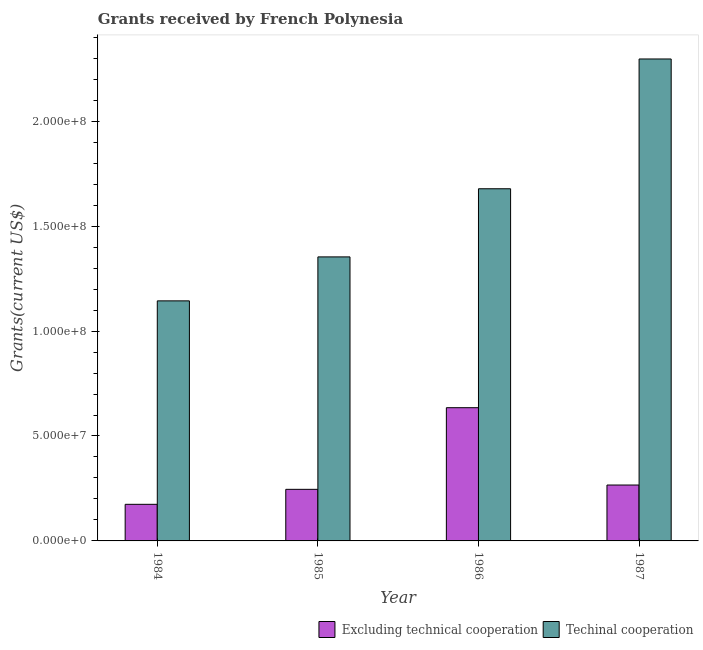How many different coloured bars are there?
Your answer should be very brief. 2. How many bars are there on the 1st tick from the left?
Your answer should be very brief. 2. How many bars are there on the 3rd tick from the right?
Ensure brevity in your answer.  2. What is the label of the 3rd group of bars from the left?
Offer a very short reply. 1986. In how many cases, is the number of bars for a given year not equal to the number of legend labels?
Your answer should be compact. 0. What is the amount of grants received(including technical cooperation) in 1984?
Your answer should be very brief. 1.14e+08. Across all years, what is the maximum amount of grants received(excluding technical cooperation)?
Keep it short and to the point. 6.35e+07. Across all years, what is the minimum amount of grants received(excluding technical cooperation)?
Your answer should be compact. 1.74e+07. What is the total amount of grants received(including technical cooperation) in the graph?
Offer a terse response. 6.47e+08. What is the difference between the amount of grants received(excluding technical cooperation) in 1985 and that in 1986?
Your answer should be very brief. -3.89e+07. What is the difference between the amount of grants received(including technical cooperation) in 1986 and the amount of grants received(excluding technical cooperation) in 1987?
Give a very brief answer. -6.18e+07. What is the average amount of grants received(excluding technical cooperation) per year?
Give a very brief answer. 3.30e+07. In how many years, is the amount of grants received(excluding technical cooperation) greater than 170000000 US$?
Make the answer very short. 0. What is the ratio of the amount of grants received(including technical cooperation) in 1984 to that in 1985?
Ensure brevity in your answer.  0.85. What is the difference between the highest and the second highest amount of grants received(including technical cooperation)?
Provide a short and direct response. 6.18e+07. What is the difference between the highest and the lowest amount of grants received(including technical cooperation)?
Offer a very short reply. 1.15e+08. In how many years, is the amount of grants received(excluding technical cooperation) greater than the average amount of grants received(excluding technical cooperation) taken over all years?
Your answer should be very brief. 1. What does the 1st bar from the left in 1986 represents?
Give a very brief answer. Excluding technical cooperation. What does the 2nd bar from the right in 1987 represents?
Offer a very short reply. Excluding technical cooperation. Are all the bars in the graph horizontal?
Offer a terse response. No. Does the graph contain any zero values?
Your response must be concise. No. Does the graph contain grids?
Provide a succinct answer. No. How many legend labels are there?
Provide a short and direct response. 2. How are the legend labels stacked?
Your answer should be compact. Horizontal. What is the title of the graph?
Provide a short and direct response. Grants received by French Polynesia. What is the label or title of the X-axis?
Provide a succinct answer. Year. What is the label or title of the Y-axis?
Your response must be concise. Grants(current US$). What is the Grants(current US$) in Excluding technical cooperation in 1984?
Provide a succinct answer. 1.74e+07. What is the Grants(current US$) of Techinal cooperation in 1984?
Your answer should be very brief. 1.14e+08. What is the Grants(current US$) of Excluding technical cooperation in 1985?
Your answer should be very brief. 2.46e+07. What is the Grants(current US$) of Techinal cooperation in 1985?
Your answer should be compact. 1.35e+08. What is the Grants(current US$) in Excluding technical cooperation in 1986?
Make the answer very short. 6.35e+07. What is the Grants(current US$) in Techinal cooperation in 1986?
Offer a terse response. 1.68e+08. What is the Grants(current US$) of Excluding technical cooperation in 1987?
Provide a succinct answer. 2.66e+07. What is the Grants(current US$) in Techinal cooperation in 1987?
Ensure brevity in your answer.  2.30e+08. Across all years, what is the maximum Grants(current US$) in Excluding technical cooperation?
Ensure brevity in your answer.  6.35e+07. Across all years, what is the maximum Grants(current US$) of Techinal cooperation?
Provide a short and direct response. 2.30e+08. Across all years, what is the minimum Grants(current US$) of Excluding technical cooperation?
Offer a terse response. 1.74e+07. Across all years, what is the minimum Grants(current US$) of Techinal cooperation?
Provide a short and direct response. 1.14e+08. What is the total Grants(current US$) in Excluding technical cooperation in the graph?
Your answer should be compact. 1.32e+08. What is the total Grants(current US$) in Techinal cooperation in the graph?
Offer a very short reply. 6.47e+08. What is the difference between the Grants(current US$) in Excluding technical cooperation in 1984 and that in 1985?
Ensure brevity in your answer.  -7.14e+06. What is the difference between the Grants(current US$) in Techinal cooperation in 1984 and that in 1985?
Ensure brevity in your answer.  -2.10e+07. What is the difference between the Grants(current US$) in Excluding technical cooperation in 1984 and that in 1986?
Provide a short and direct response. -4.60e+07. What is the difference between the Grants(current US$) in Techinal cooperation in 1984 and that in 1986?
Provide a short and direct response. -5.34e+07. What is the difference between the Grants(current US$) of Excluding technical cooperation in 1984 and that in 1987?
Offer a terse response. -9.20e+06. What is the difference between the Grants(current US$) of Techinal cooperation in 1984 and that in 1987?
Give a very brief answer. -1.15e+08. What is the difference between the Grants(current US$) of Excluding technical cooperation in 1985 and that in 1986?
Provide a succinct answer. -3.89e+07. What is the difference between the Grants(current US$) in Techinal cooperation in 1985 and that in 1986?
Offer a terse response. -3.25e+07. What is the difference between the Grants(current US$) in Excluding technical cooperation in 1985 and that in 1987?
Provide a succinct answer. -2.06e+06. What is the difference between the Grants(current US$) of Techinal cooperation in 1985 and that in 1987?
Offer a terse response. -9.43e+07. What is the difference between the Grants(current US$) in Excluding technical cooperation in 1986 and that in 1987?
Make the answer very short. 3.68e+07. What is the difference between the Grants(current US$) in Techinal cooperation in 1986 and that in 1987?
Offer a very short reply. -6.18e+07. What is the difference between the Grants(current US$) in Excluding technical cooperation in 1984 and the Grants(current US$) in Techinal cooperation in 1985?
Give a very brief answer. -1.18e+08. What is the difference between the Grants(current US$) in Excluding technical cooperation in 1984 and the Grants(current US$) in Techinal cooperation in 1986?
Make the answer very short. -1.50e+08. What is the difference between the Grants(current US$) of Excluding technical cooperation in 1984 and the Grants(current US$) of Techinal cooperation in 1987?
Give a very brief answer. -2.12e+08. What is the difference between the Grants(current US$) in Excluding technical cooperation in 1985 and the Grants(current US$) in Techinal cooperation in 1986?
Keep it short and to the point. -1.43e+08. What is the difference between the Grants(current US$) in Excluding technical cooperation in 1985 and the Grants(current US$) in Techinal cooperation in 1987?
Provide a short and direct response. -2.05e+08. What is the difference between the Grants(current US$) of Excluding technical cooperation in 1986 and the Grants(current US$) of Techinal cooperation in 1987?
Offer a very short reply. -1.66e+08. What is the average Grants(current US$) of Excluding technical cooperation per year?
Your answer should be compact. 3.30e+07. What is the average Grants(current US$) in Techinal cooperation per year?
Ensure brevity in your answer.  1.62e+08. In the year 1984, what is the difference between the Grants(current US$) in Excluding technical cooperation and Grants(current US$) in Techinal cooperation?
Your response must be concise. -9.70e+07. In the year 1985, what is the difference between the Grants(current US$) of Excluding technical cooperation and Grants(current US$) of Techinal cooperation?
Provide a succinct answer. -1.11e+08. In the year 1986, what is the difference between the Grants(current US$) of Excluding technical cooperation and Grants(current US$) of Techinal cooperation?
Provide a succinct answer. -1.04e+08. In the year 1987, what is the difference between the Grants(current US$) in Excluding technical cooperation and Grants(current US$) in Techinal cooperation?
Offer a very short reply. -2.03e+08. What is the ratio of the Grants(current US$) in Excluding technical cooperation in 1984 to that in 1985?
Give a very brief answer. 0.71. What is the ratio of the Grants(current US$) of Techinal cooperation in 1984 to that in 1985?
Provide a short and direct response. 0.85. What is the ratio of the Grants(current US$) of Excluding technical cooperation in 1984 to that in 1986?
Make the answer very short. 0.27. What is the ratio of the Grants(current US$) of Techinal cooperation in 1984 to that in 1986?
Offer a very short reply. 0.68. What is the ratio of the Grants(current US$) of Excluding technical cooperation in 1984 to that in 1987?
Give a very brief answer. 0.65. What is the ratio of the Grants(current US$) of Techinal cooperation in 1984 to that in 1987?
Your answer should be very brief. 0.5. What is the ratio of the Grants(current US$) of Excluding technical cooperation in 1985 to that in 1986?
Provide a short and direct response. 0.39. What is the ratio of the Grants(current US$) in Techinal cooperation in 1985 to that in 1986?
Provide a succinct answer. 0.81. What is the ratio of the Grants(current US$) of Excluding technical cooperation in 1985 to that in 1987?
Your answer should be very brief. 0.92. What is the ratio of the Grants(current US$) in Techinal cooperation in 1985 to that in 1987?
Your response must be concise. 0.59. What is the ratio of the Grants(current US$) of Excluding technical cooperation in 1986 to that in 1987?
Ensure brevity in your answer.  2.38. What is the ratio of the Grants(current US$) of Techinal cooperation in 1986 to that in 1987?
Ensure brevity in your answer.  0.73. What is the difference between the highest and the second highest Grants(current US$) of Excluding technical cooperation?
Give a very brief answer. 3.68e+07. What is the difference between the highest and the second highest Grants(current US$) in Techinal cooperation?
Give a very brief answer. 6.18e+07. What is the difference between the highest and the lowest Grants(current US$) in Excluding technical cooperation?
Offer a terse response. 4.60e+07. What is the difference between the highest and the lowest Grants(current US$) of Techinal cooperation?
Your answer should be compact. 1.15e+08. 